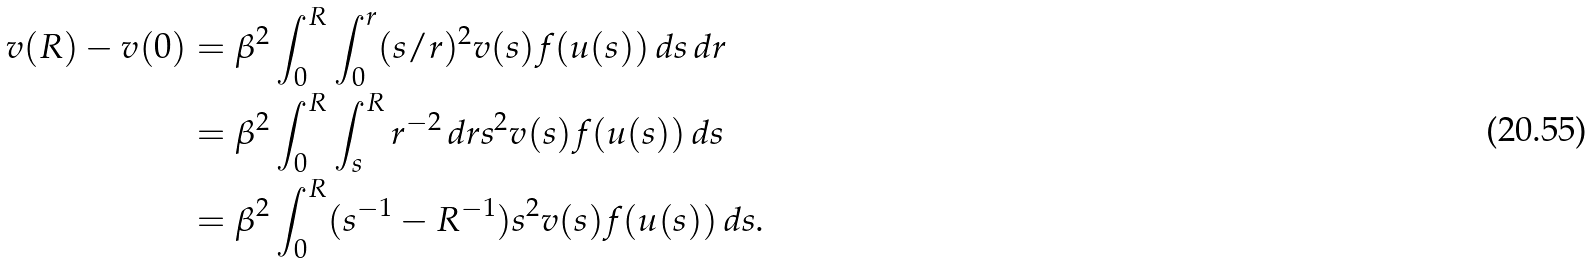Convert formula to latex. <formula><loc_0><loc_0><loc_500><loc_500>v ( R ) - v ( 0 ) & = \beta ^ { 2 } \int _ { 0 } ^ { R } \int _ { 0 } ^ { r } ( s / r ) ^ { 2 } v ( s ) f ( u ( s ) ) \, d s \, d r \\ & = \beta ^ { 2 } \int _ { 0 } ^ { R } \int _ { s } ^ { R } r ^ { - 2 } \, d r s ^ { 2 } v ( s ) f ( u ( s ) ) \, d s \\ & = \beta ^ { 2 } \int _ { 0 } ^ { R } ( s ^ { - 1 } - R ^ { - 1 } ) s ^ { 2 } v ( s ) f ( u ( s ) ) \, d s .</formula> 